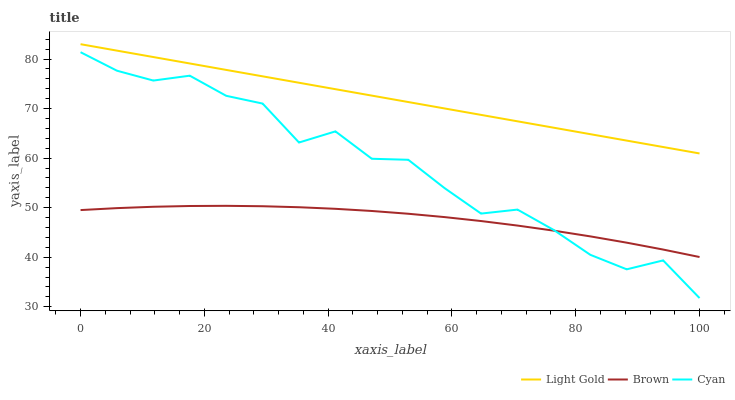Does Brown have the minimum area under the curve?
Answer yes or no. Yes. Does Light Gold have the maximum area under the curve?
Answer yes or no. Yes. Does Cyan have the minimum area under the curve?
Answer yes or no. No. Does Cyan have the maximum area under the curve?
Answer yes or no. No. Is Light Gold the smoothest?
Answer yes or no. Yes. Is Cyan the roughest?
Answer yes or no. Yes. Is Cyan the smoothest?
Answer yes or no. No. Is Light Gold the roughest?
Answer yes or no. No. Does Cyan have the lowest value?
Answer yes or no. Yes. Does Light Gold have the lowest value?
Answer yes or no. No. Does Light Gold have the highest value?
Answer yes or no. Yes. Does Cyan have the highest value?
Answer yes or no. No. Is Cyan less than Light Gold?
Answer yes or no. Yes. Is Light Gold greater than Brown?
Answer yes or no. Yes. Does Brown intersect Cyan?
Answer yes or no. Yes. Is Brown less than Cyan?
Answer yes or no. No. Is Brown greater than Cyan?
Answer yes or no. No. Does Cyan intersect Light Gold?
Answer yes or no. No. 